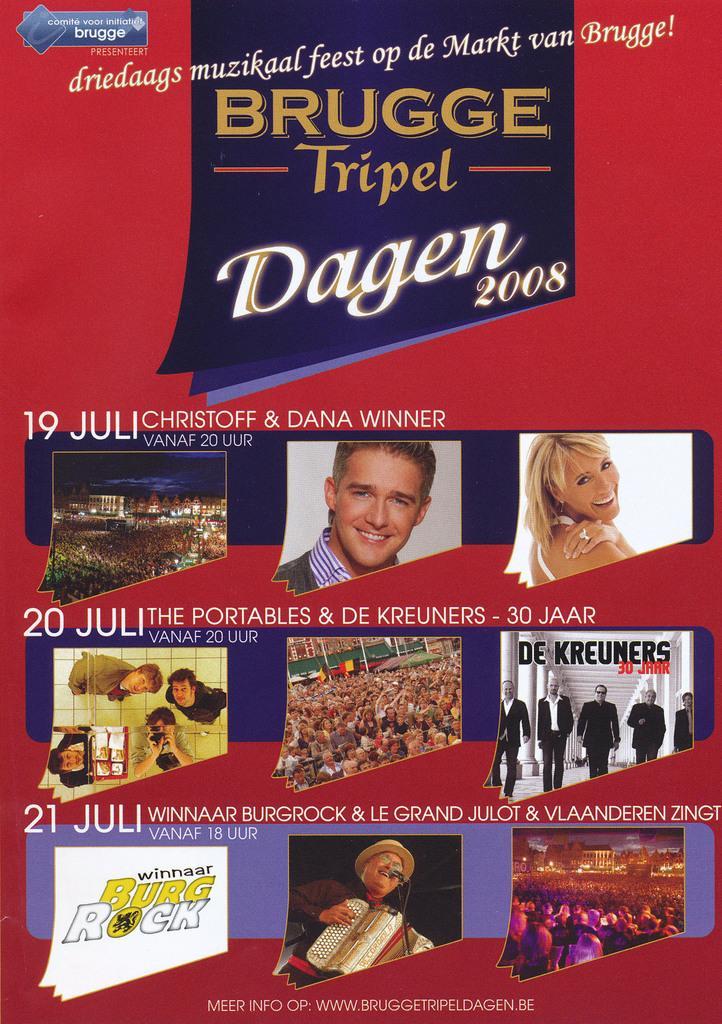Could you give a brief overview of what you see in this image? In this picture we can see a poster. Few people are visible in this poster. 